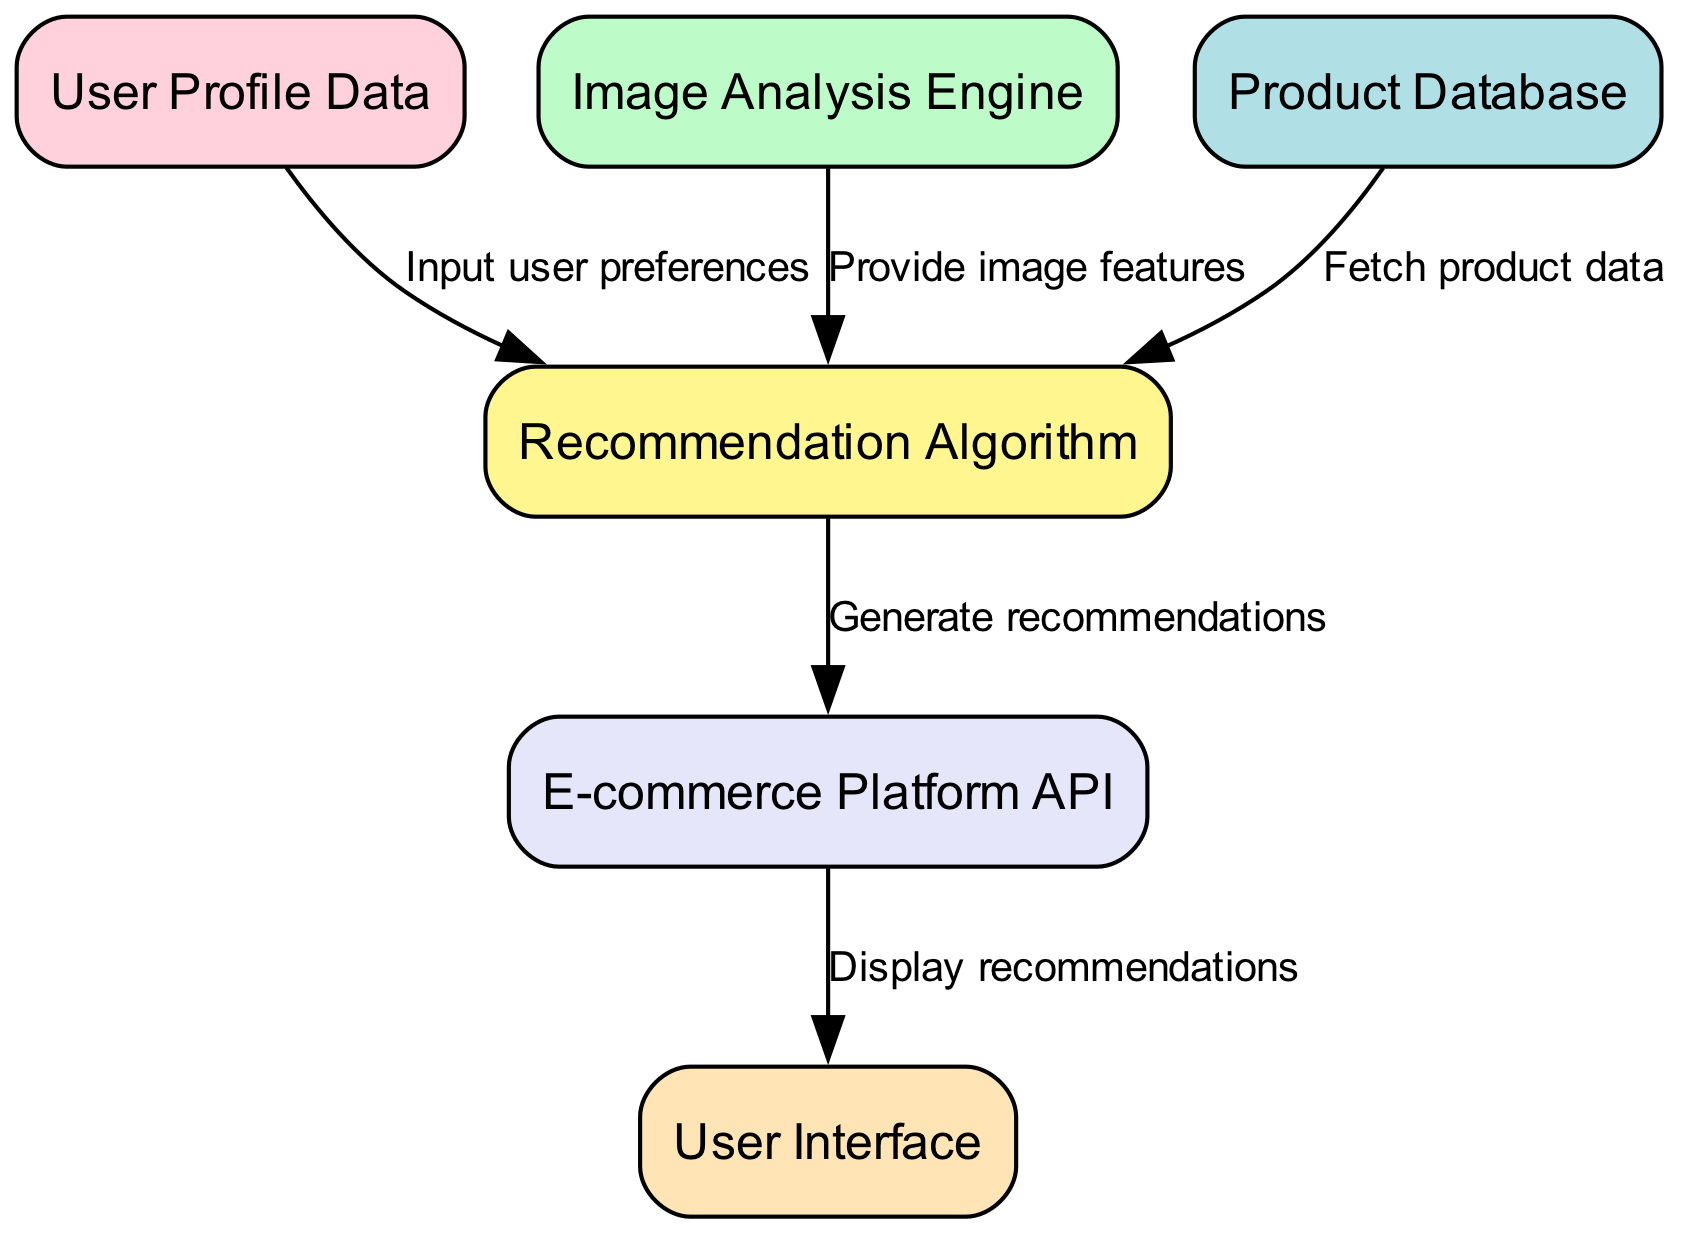What are the input sources for the recommendation algorithm? The recommendation algorithm receives input from three sources: User Profile Data, Image Analysis Engine, and Product Database. These inputs provide user preferences, image features, and product data respectively.
Answer: User Profile Data, Image Analysis Engine, Product Database How many edges are in the diagram? To find the number of edges, we count the connections illustrated between the nodes. There are five connections depicted in the diagram, indicating the relationships and flow of data between different components.
Answer: 5 What does the E-commerce Platform API output? The E-commerce Platform API generates output based on the recommendations that are created by the recommendation algorithm. It is responsible for forwarding the generated recommendations to the user interface for display.
Answer: Generate recommendations Which node provides image features to the recommendation algorithm? The edge that connects the Image Analysis Engine to the Recommendation Algorithm indicates that it supplies image features. This relationship allows the recommendation system to consider visual attributes of products.
Answer: Image Analysis Engine What is the relationship between the Recommendation Algorithm and the User Interface? The Recommendation Algorithm provides the output it generates to the User Interface through a connecting edge from the recommendation algorithm to the e-commerce platform API, which subsequently interacts with the user interface to display these recommendations.
Answer: Display recommendations Which component collects user preferences? The User Profile Data node is responsible for collecting user preferences. This information is vital for tailoring recommendations according to individual user tastes and browsing history.
Answer: User Profile Data What does the Product Database feed into? The Product Database supplies product data to the Recommendation Algorithm, which uses this information alongside other inputs to generate personalized recommendations for users.
Answer: Recommendation Algorithm How many nodes are there in the diagram? By counting the distinct components shown in the diagram, we can determine the number of nodes present. Here, we counted the six nodes that represent different elements involved in the recommendation system.
Answer: 6 What is the order of data flow from user profile to display? The flow starts from User Profile Data to the Recommendation Algorithm, which then goes to the E-commerce Platform API, and finally to the User Interface for displaying the recommendations. This sequential flow delineates how data transitions to reach the end-user.
Answer: User Profile Data -> Recommendation Algorithm -> E-commerce Platform API -> User Interface 